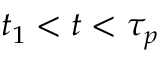Convert formula to latex. <formula><loc_0><loc_0><loc_500><loc_500>t _ { 1 } < t < \tau _ { p }</formula> 